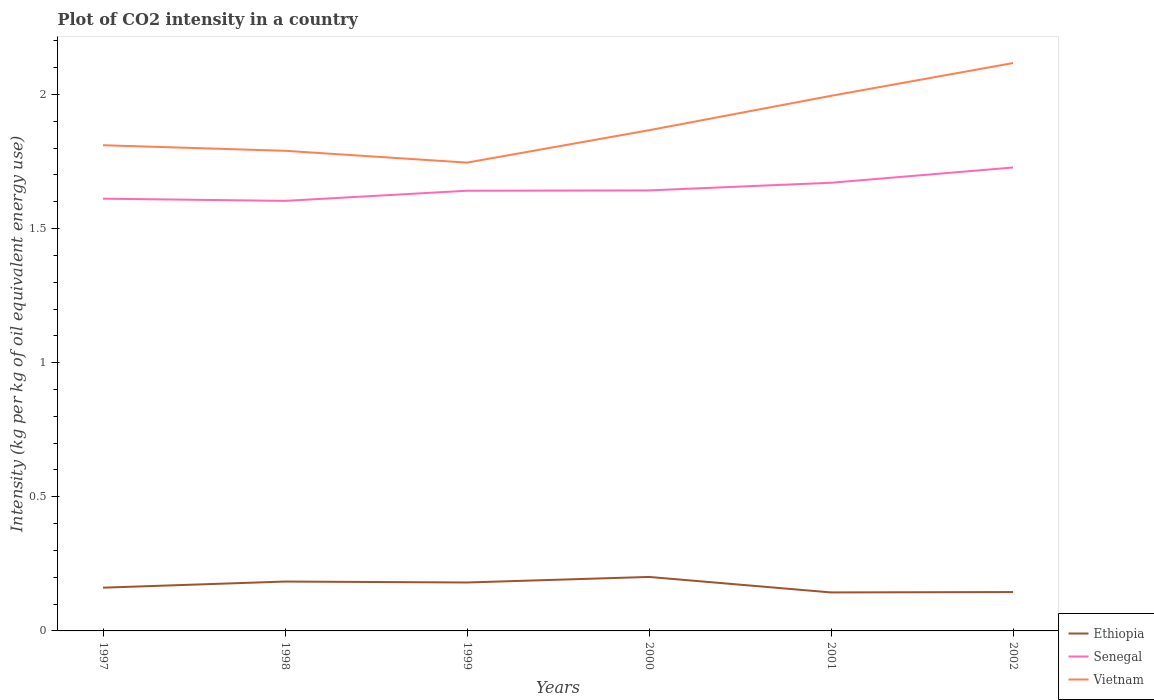How many different coloured lines are there?
Provide a short and direct response. 3. Across all years, what is the maximum CO2 intensity in in Vietnam?
Provide a short and direct response. 1.75. In which year was the CO2 intensity in in Vietnam maximum?
Your answer should be very brief. 1999. What is the total CO2 intensity in in Senegal in the graph?
Offer a terse response. -0.04. What is the difference between the highest and the second highest CO2 intensity in in Senegal?
Your response must be concise. 0.12. Is the CO2 intensity in in Vietnam strictly greater than the CO2 intensity in in Ethiopia over the years?
Give a very brief answer. No. How many years are there in the graph?
Keep it short and to the point. 6. What is the difference between two consecutive major ticks on the Y-axis?
Give a very brief answer. 0.5. Are the values on the major ticks of Y-axis written in scientific E-notation?
Provide a succinct answer. No. Where does the legend appear in the graph?
Ensure brevity in your answer.  Bottom right. How are the legend labels stacked?
Your response must be concise. Vertical. What is the title of the graph?
Provide a short and direct response. Plot of CO2 intensity in a country. What is the label or title of the X-axis?
Give a very brief answer. Years. What is the label or title of the Y-axis?
Your answer should be compact. Intensity (kg per kg of oil equivalent energy use). What is the Intensity (kg per kg of oil equivalent energy use) of Ethiopia in 1997?
Make the answer very short. 0.16. What is the Intensity (kg per kg of oil equivalent energy use) in Senegal in 1997?
Provide a short and direct response. 1.61. What is the Intensity (kg per kg of oil equivalent energy use) of Vietnam in 1997?
Provide a short and direct response. 1.81. What is the Intensity (kg per kg of oil equivalent energy use) of Ethiopia in 1998?
Your response must be concise. 0.18. What is the Intensity (kg per kg of oil equivalent energy use) in Senegal in 1998?
Your response must be concise. 1.6. What is the Intensity (kg per kg of oil equivalent energy use) of Vietnam in 1998?
Provide a succinct answer. 1.79. What is the Intensity (kg per kg of oil equivalent energy use) in Ethiopia in 1999?
Ensure brevity in your answer.  0.18. What is the Intensity (kg per kg of oil equivalent energy use) in Senegal in 1999?
Give a very brief answer. 1.64. What is the Intensity (kg per kg of oil equivalent energy use) of Vietnam in 1999?
Your response must be concise. 1.75. What is the Intensity (kg per kg of oil equivalent energy use) of Ethiopia in 2000?
Offer a terse response. 0.2. What is the Intensity (kg per kg of oil equivalent energy use) in Senegal in 2000?
Offer a terse response. 1.64. What is the Intensity (kg per kg of oil equivalent energy use) of Vietnam in 2000?
Provide a short and direct response. 1.87. What is the Intensity (kg per kg of oil equivalent energy use) in Ethiopia in 2001?
Provide a succinct answer. 0.14. What is the Intensity (kg per kg of oil equivalent energy use) in Senegal in 2001?
Provide a succinct answer. 1.67. What is the Intensity (kg per kg of oil equivalent energy use) in Vietnam in 2001?
Keep it short and to the point. 2. What is the Intensity (kg per kg of oil equivalent energy use) of Ethiopia in 2002?
Make the answer very short. 0.14. What is the Intensity (kg per kg of oil equivalent energy use) in Senegal in 2002?
Provide a succinct answer. 1.73. What is the Intensity (kg per kg of oil equivalent energy use) of Vietnam in 2002?
Your answer should be very brief. 2.12. Across all years, what is the maximum Intensity (kg per kg of oil equivalent energy use) in Ethiopia?
Give a very brief answer. 0.2. Across all years, what is the maximum Intensity (kg per kg of oil equivalent energy use) in Senegal?
Offer a terse response. 1.73. Across all years, what is the maximum Intensity (kg per kg of oil equivalent energy use) of Vietnam?
Make the answer very short. 2.12. Across all years, what is the minimum Intensity (kg per kg of oil equivalent energy use) of Ethiopia?
Provide a short and direct response. 0.14. Across all years, what is the minimum Intensity (kg per kg of oil equivalent energy use) in Senegal?
Make the answer very short. 1.6. Across all years, what is the minimum Intensity (kg per kg of oil equivalent energy use) in Vietnam?
Give a very brief answer. 1.75. What is the total Intensity (kg per kg of oil equivalent energy use) of Ethiopia in the graph?
Offer a very short reply. 1.02. What is the total Intensity (kg per kg of oil equivalent energy use) in Senegal in the graph?
Your answer should be compact. 9.9. What is the total Intensity (kg per kg of oil equivalent energy use) in Vietnam in the graph?
Provide a succinct answer. 11.33. What is the difference between the Intensity (kg per kg of oil equivalent energy use) of Ethiopia in 1997 and that in 1998?
Your answer should be compact. -0.02. What is the difference between the Intensity (kg per kg of oil equivalent energy use) of Senegal in 1997 and that in 1998?
Keep it short and to the point. 0.01. What is the difference between the Intensity (kg per kg of oil equivalent energy use) of Vietnam in 1997 and that in 1998?
Your response must be concise. 0.02. What is the difference between the Intensity (kg per kg of oil equivalent energy use) in Ethiopia in 1997 and that in 1999?
Provide a succinct answer. -0.02. What is the difference between the Intensity (kg per kg of oil equivalent energy use) of Senegal in 1997 and that in 1999?
Give a very brief answer. -0.03. What is the difference between the Intensity (kg per kg of oil equivalent energy use) of Vietnam in 1997 and that in 1999?
Your answer should be very brief. 0.06. What is the difference between the Intensity (kg per kg of oil equivalent energy use) of Ethiopia in 1997 and that in 2000?
Keep it short and to the point. -0.04. What is the difference between the Intensity (kg per kg of oil equivalent energy use) in Senegal in 1997 and that in 2000?
Keep it short and to the point. -0.03. What is the difference between the Intensity (kg per kg of oil equivalent energy use) of Vietnam in 1997 and that in 2000?
Give a very brief answer. -0.06. What is the difference between the Intensity (kg per kg of oil equivalent energy use) of Ethiopia in 1997 and that in 2001?
Your answer should be compact. 0.02. What is the difference between the Intensity (kg per kg of oil equivalent energy use) of Senegal in 1997 and that in 2001?
Provide a succinct answer. -0.06. What is the difference between the Intensity (kg per kg of oil equivalent energy use) of Vietnam in 1997 and that in 2001?
Provide a short and direct response. -0.18. What is the difference between the Intensity (kg per kg of oil equivalent energy use) in Ethiopia in 1997 and that in 2002?
Keep it short and to the point. 0.02. What is the difference between the Intensity (kg per kg of oil equivalent energy use) of Senegal in 1997 and that in 2002?
Your answer should be very brief. -0.12. What is the difference between the Intensity (kg per kg of oil equivalent energy use) in Vietnam in 1997 and that in 2002?
Provide a succinct answer. -0.31. What is the difference between the Intensity (kg per kg of oil equivalent energy use) of Ethiopia in 1998 and that in 1999?
Provide a short and direct response. 0. What is the difference between the Intensity (kg per kg of oil equivalent energy use) of Senegal in 1998 and that in 1999?
Your answer should be very brief. -0.04. What is the difference between the Intensity (kg per kg of oil equivalent energy use) of Vietnam in 1998 and that in 1999?
Your response must be concise. 0.04. What is the difference between the Intensity (kg per kg of oil equivalent energy use) in Ethiopia in 1998 and that in 2000?
Ensure brevity in your answer.  -0.02. What is the difference between the Intensity (kg per kg of oil equivalent energy use) in Senegal in 1998 and that in 2000?
Give a very brief answer. -0.04. What is the difference between the Intensity (kg per kg of oil equivalent energy use) in Vietnam in 1998 and that in 2000?
Provide a succinct answer. -0.08. What is the difference between the Intensity (kg per kg of oil equivalent energy use) of Ethiopia in 1998 and that in 2001?
Your response must be concise. 0.04. What is the difference between the Intensity (kg per kg of oil equivalent energy use) of Senegal in 1998 and that in 2001?
Your response must be concise. -0.07. What is the difference between the Intensity (kg per kg of oil equivalent energy use) of Vietnam in 1998 and that in 2001?
Provide a short and direct response. -0.2. What is the difference between the Intensity (kg per kg of oil equivalent energy use) of Ethiopia in 1998 and that in 2002?
Your response must be concise. 0.04. What is the difference between the Intensity (kg per kg of oil equivalent energy use) of Senegal in 1998 and that in 2002?
Make the answer very short. -0.12. What is the difference between the Intensity (kg per kg of oil equivalent energy use) of Vietnam in 1998 and that in 2002?
Offer a very short reply. -0.33. What is the difference between the Intensity (kg per kg of oil equivalent energy use) in Ethiopia in 1999 and that in 2000?
Give a very brief answer. -0.02. What is the difference between the Intensity (kg per kg of oil equivalent energy use) of Senegal in 1999 and that in 2000?
Your response must be concise. -0. What is the difference between the Intensity (kg per kg of oil equivalent energy use) in Vietnam in 1999 and that in 2000?
Keep it short and to the point. -0.12. What is the difference between the Intensity (kg per kg of oil equivalent energy use) of Ethiopia in 1999 and that in 2001?
Ensure brevity in your answer.  0.04. What is the difference between the Intensity (kg per kg of oil equivalent energy use) in Senegal in 1999 and that in 2001?
Your answer should be very brief. -0.03. What is the difference between the Intensity (kg per kg of oil equivalent energy use) of Vietnam in 1999 and that in 2001?
Make the answer very short. -0.25. What is the difference between the Intensity (kg per kg of oil equivalent energy use) in Ethiopia in 1999 and that in 2002?
Your response must be concise. 0.04. What is the difference between the Intensity (kg per kg of oil equivalent energy use) of Senegal in 1999 and that in 2002?
Provide a short and direct response. -0.09. What is the difference between the Intensity (kg per kg of oil equivalent energy use) in Vietnam in 1999 and that in 2002?
Give a very brief answer. -0.37. What is the difference between the Intensity (kg per kg of oil equivalent energy use) of Ethiopia in 2000 and that in 2001?
Your answer should be very brief. 0.06. What is the difference between the Intensity (kg per kg of oil equivalent energy use) of Senegal in 2000 and that in 2001?
Give a very brief answer. -0.03. What is the difference between the Intensity (kg per kg of oil equivalent energy use) in Vietnam in 2000 and that in 2001?
Provide a short and direct response. -0.13. What is the difference between the Intensity (kg per kg of oil equivalent energy use) in Ethiopia in 2000 and that in 2002?
Your answer should be very brief. 0.06. What is the difference between the Intensity (kg per kg of oil equivalent energy use) in Senegal in 2000 and that in 2002?
Make the answer very short. -0.09. What is the difference between the Intensity (kg per kg of oil equivalent energy use) in Vietnam in 2000 and that in 2002?
Your answer should be very brief. -0.25. What is the difference between the Intensity (kg per kg of oil equivalent energy use) in Ethiopia in 2001 and that in 2002?
Keep it short and to the point. -0. What is the difference between the Intensity (kg per kg of oil equivalent energy use) in Senegal in 2001 and that in 2002?
Keep it short and to the point. -0.06. What is the difference between the Intensity (kg per kg of oil equivalent energy use) of Vietnam in 2001 and that in 2002?
Provide a short and direct response. -0.12. What is the difference between the Intensity (kg per kg of oil equivalent energy use) in Ethiopia in 1997 and the Intensity (kg per kg of oil equivalent energy use) in Senegal in 1998?
Offer a terse response. -1.44. What is the difference between the Intensity (kg per kg of oil equivalent energy use) in Ethiopia in 1997 and the Intensity (kg per kg of oil equivalent energy use) in Vietnam in 1998?
Ensure brevity in your answer.  -1.63. What is the difference between the Intensity (kg per kg of oil equivalent energy use) of Senegal in 1997 and the Intensity (kg per kg of oil equivalent energy use) of Vietnam in 1998?
Give a very brief answer. -0.18. What is the difference between the Intensity (kg per kg of oil equivalent energy use) in Ethiopia in 1997 and the Intensity (kg per kg of oil equivalent energy use) in Senegal in 1999?
Offer a very short reply. -1.48. What is the difference between the Intensity (kg per kg of oil equivalent energy use) in Ethiopia in 1997 and the Intensity (kg per kg of oil equivalent energy use) in Vietnam in 1999?
Give a very brief answer. -1.58. What is the difference between the Intensity (kg per kg of oil equivalent energy use) of Senegal in 1997 and the Intensity (kg per kg of oil equivalent energy use) of Vietnam in 1999?
Your answer should be very brief. -0.13. What is the difference between the Intensity (kg per kg of oil equivalent energy use) in Ethiopia in 1997 and the Intensity (kg per kg of oil equivalent energy use) in Senegal in 2000?
Your answer should be very brief. -1.48. What is the difference between the Intensity (kg per kg of oil equivalent energy use) in Ethiopia in 1997 and the Intensity (kg per kg of oil equivalent energy use) in Vietnam in 2000?
Your answer should be very brief. -1.71. What is the difference between the Intensity (kg per kg of oil equivalent energy use) in Senegal in 1997 and the Intensity (kg per kg of oil equivalent energy use) in Vietnam in 2000?
Provide a succinct answer. -0.26. What is the difference between the Intensity (kg per kg of oil equivalent energy use) of Ethiopia in 1997 and the Intensity (kg per kg of oil equivalent energy use) of Senegal in 2001?
Your answer should be compact. -1.51. What is the difference between the Intensity (kg per kg of oil equivalent energy use) in Ethiopia in 1997 and the Intensity (kg per kg of oil equivalent energy use) in Vietnam in 2001?
Your answer should be compact. -1.83. What is the difference between the Intensity (kg per kg of oil equivalent energy use) of Senegal in 1997 and the Intensity (kg per kg of oil equivalent energy use) of Vietnam in 2001?
Ensure brevity in your answer.  -0.38. What is the difference between the Intensity (kg per kg of oil equivalent energy use) in Ethiopia in 1997 and the Intensity (kg per kg of oil equivalent energy use) in Senegal in 2002?
Your response must be concise. -1.57. What is the difference between the Intensity (kg per kg of oil equivalent energy use) in Ethiopia in 1997 and the Intensity (kg per kg of oil equivalent energy use) in Vietnam in 2002?
Ensure brevity in your answer.  -1.96. What is the difference between the Intensity (kg per kg of oil equivalent energy use) of Senegal in 1997 and the Intensity (kg per kg of oil equivalent energy use) of Vietnam in 2002?
Provide a short and direct response. -0.51. What is the difference between the Intensity (kg per kg of oil equivalent energy use) of Ethiopia in 1998 and the Intensity (kg per kg of oil equivalent energy use) of Senegal in 1999?
Your answer should be compact. -1.46. What is the difference between the Intensity (kg per kg of oil equivalent energy use) in Ethiopia in 1998 and the Intensity (kg per kg of oil equivalent energy use) in Vietnam in 1999?
Make the answer very short. -1.56. What is the difference between the Intensity (kg per kg of oil equivalent energy use) of Senegal in 1998 and the Intensity (kg per kg of oil equivalent energy use) of Vietnam in 1999?
Make the answer very short. -0.14. What is the difference between the Intensity (kg per kg of oil equivalent energy use) in Ethiopia in 1998 and the Intensity (kg per kg of oil equivalent energy use) in Senegal in 2000?
Your response must be concise. -1.46. What is the difference between the Intensity (kg per kg of oil equivalent energy use) in Ethiopia in 1998 and the Intensity (kg per kg of oil equivalent energy use) in Vietnam in 2000?
Your response must be concise. -1.68. What is the difference between the Intensity (kg per kg of oil equivalent energy use) in Senegal in 1998 and the Intensity (kg per kg of oil equivalent energy use) in Vietnam in 2000?
Provide a succinct answer. -0.26. What is the difference between the Intensity (kg per kg of oil equivalent energy use) of Ethiopia in 1998 and the Intensity (kg per kg of oil equivalent energy use) of Senegal in 2001?
Your answer should be compact. -1.49. What is the difference between the Intensity (kg per kg of oil equivalent energy use) in Ethiopia in 1998 and the Intensity (kg per kg of oil equivalent energy use) in Vietnam in 2001?
Offer a very short reply. -1.81. What is the difference between the Intensity (kg per kg of oil equivalent energy use) of Senegal in 1998 and the Intensity (kg per kg of oil equivalent energy use) of Vietnam in 2001?
Your answer should be very brief. -0.39. What is the difference between the Intensity (kg per kg of oil equivalent energy use) of Ethiopia in 1998 and the Intensity (kg per kg of oil equivalent energy use) of Senegal in 2002?
Give a very brief answer. -1.54. What is the difference between the Intensity (kg per kg of oil equivalent energy use) of Ethiopia in 1998 and the Intensity (kg per kg of oil equivalent energy use) of Vietnam in 2002?
Offer a very short reply. -1.93. What is the difference between the Intensity (kg per kg of oil equivalent energy use) in Senegal in 1998 and the Intensity (kg per kg of oil equivalent energy use) in Vietnam in 2002?
Your answer should be compact. -0.51. What is the difference between the Intensity (kg per kg of oil equivalent energy use) of Ethiopia in 1999 and the Intensity (kg per kg of oil equivalent energy use) of Senegal in 2000?
Ensure brevity in your answer.  -1.46. What is the difference between the Intensity (kg per kg of oil equivalent energy use) of Ethiopia in 1999 and the Intensity (kg per kg of oil equivalent energy use) of Vietnam in 2000?
Offer a terse response. -1.69. What is the difference between the Intensity (kg per kg of oil equivalent energy use) of Senegal in 1999 and the Intensity (kg per kg of oil equivalent energy use) of Vietnam in 2000?
Ensure brevity in your answer.  -0.23. What is the difference between the Intensity (kg per kg of oil equivalent energy use) of Ethiopia in 1999 and the Intensity (kg per kg of oil equivalent energy use) of Senegal in 2001?
Ensure brevity in your answer.  -1.49. What is the difference between the Intensity (kg per kg of oil equivalent energy use) in Ethiopia in 1999 and the Intensity (kg per kg of oil equivalent energy use) in Vietnam in 2001?
Your response must be concise. -1.81. What is the difference between the Intensity (kg per kg of oil equivalent energy use) of Senegal in 1999 and the Intensity (kg per kg of oil equivalent energy use) of Vietnam in 2001?
Provide a short and direct response. -0.35. What is the difference between the Intensity (kg per kg of oil equivalent energy use) in Ethiopia in 1999 and the Intensity (kg per kg of oil equivalent energy use) in Senegal in 2002?
Ensure brevity in your answer.  -1.55. What is the difference between the Intensity (kg per kg of oil equivalent energy use) in Ethiopia in 1999 and the Intensity (kg per kg of oil equivalent energy use) in Vietnam in 2002?
Ensure brevity in your answer.  -1.94. What is the difference between the Intensity (kg per kg of oil equivalent energy use) of Senegal in 1999 and the Intensity (kg per kg of oil equivalent energy use) of Vietnam in 2002?
Provide a succinct answer. -0.48. What is the difference between the Intensity (kg per kg of oil equivalent energy use) of Ethiopia in 2000 and the Intensity (kg per kg of oil equivalent energy use) of Senegal in 2001?
Ensure brevity in your answer.  -1.47. What is the difference between the Intensity (kg per kg of oil equivalent energy use) of Ethiopia in 2000 and the Intensity (kg per kg of oil equivalent energy use) of Vietnam in 2001?
Give a very brief answer. -1.79. What is the difference between the Intensity (kg per kg of oil equivalent energy use) in Senegal in 2000 and the Intensity (kg per kg of oil equivalent energy use) in Vietnam in 2001?
Give a very brief answer. -0.35. What is the difference between the Intensity (kg per kg of oil equivalent energy use) of Ethiopia in 2000 and the Intensity (kg per kg of oil equivalent energy use) of Senegal in 2002?
Your response must be concise. -1.53. What is the difference between the Intensity (kg per kg of oil equivalent energy use) in Ethiopia in 2000 and the Intensity (kg per kg of oil equivalent energy use) in Vietnam in 2002?
Your response must be concise. -1.92. What is the difference between the Intensity (kg per kg of oil equivalent energy use) in Senegal in 2000 and the Intensity (kg per kg of oil equivalent energy use) in Vietnam in 2002?
Offer a terse response. -0.47. What is the difference between the Intensity (kg per kg of oil equivalent energy use) in Ethiopia in 2001 and the Intensity (kg per kg of oil equivalent energy use) in Senegal in 2002?
Offer a terse response. -1.58. What is the difference between the Intensity (kg per kg of oil equivalent energy use) in Ethiopia in 2001 and the Intensity (kg per kg of oil equivalent energy use) in Vietnam in 2002?
Make the answer very short. -1.97. What is the difference between the Intensity (kg per kg of oil equivalent energy use) of Senegal in 2001 and the Intensity (kg per kg of oil equivalent energy use) of Vietnam in 2002?
Provide a short and direct response. -0.45. What is the average Intensity (kg per kg of oil equivalent energy use) in Ethiopia per year?
Give a very brief answer. 0.17. What is the average Intensity (kg per kg of oil equivalent energy use) in Senegal per year?
Keep it short and to the point. 1.65. What is the average Intensity (kg per kg of oil equivalent energy use) in Vietnam per year?
Your response must be concise. 1.89. In the year 1997, what is the difference between the Intensity (kg per kg of oil equivalent energy use) in Ethiopia and Intensity (kg per kg of oil equivalent energy use) in Senegal?
Offer a very short reply. -1.45. In the year 1997, what is the difference between the Intensity (kg per kg of oil equivalent energy use) in Ethiopia and Intensity (kg per kg of oil equivalent energy use) in Vietnam?
Ensure brevity in your answer.  -1.65. In the year 1997, what is the difference between the Intensity (kg per kg of oil equivalent energy use) in Senegal and Intensity (kg per kg of oil equivalent energy use) in Vietnam?
Your answer should be compact. -0.2. In the year 1998, what is the difference between the Intensity (kg per kg of oil equivalent energy use) in Ethiopia and Intensity (kg per kg of oil equivalent energy use) in Senegal?
Offer a terse response. -1.42. In the year 1998, what is the difference between the Intensity (kg per kg of oil equivalent energy use) in Ethiopia and Intensity (kg per kg of oil equivalent energy use) in Vietnam?
Keep it short and to the point. -1.61. In the year 1998, what is the difference between the Intensity (kg per kg of oil equivalent energy use) of Senegal and Intensity (kg per kg of oil equivalent energy use) of Vietnam?
Your answer should be very brief. -0.19. In the year 1999, what is the difference between the Intensity (kg per kg of oil equivalent energy use) of Ethiopia and Intensity (kg per kg of oil equivalent energy use) of Senegal?
Give a very brief answer. -1.46. In the year 1999, what is the difference between the Intensity (kg per kg of oil equivalent energy use) in Ethiopia and Intensity (kg per kg of oil equivalent energy use) in Vietnam?
Your response must be concise. -1.57. In the year 1999, what is the difference between the Intensity (kg per kg of oil equivalent energy use) in Senegal and Intensity (kg per kg of oil equivalent energy use) in Vietnam?
Your response must be concise. -0.1. In the year 2000, what is the difference between the Intensity (kg per kg of oil equivalent energy use) of Ethiopia and Intensity (kg per kg of oil equivalent energy use) of Senegal?
Your answer should be very brief. -1.44. In the year 2000, what is the difference between the Intensity (kg per kg of oil equivalent energy use) in Ethiopia and Intensity (kg per kg of oil equivalent energy use) in Vietnam?
Provide a succinct answer. -1.67. In the year 2000, what is the difference between the Intensity (kg per kg of oil equivalent energy use) in Senegal and Intensity (kg per kg of oil equivalent energy use) in Vietnam?
Your answer should be compact. -0.22. In the year 2001, what is the difference between the Intensity (kg per kg of oil equivalent energy use) of Ethiopia and Intensity (kg per kg of oil equivalent energy use) of Senegal?
Give a very brief answer. -1.53. In the year 2001, what is the difference between the Intensity (kg per kg of oil equivalent energy use) of Ethiopia and Intensity (kg per kg of oil equivalent energy use) of Vietnam?
Offer a terse response. -1.85. In the year 2001, what is the difference between the Intensity (kg per kg of oil equivalent energy use) of Senegal and Intensity (kg per kg of oil equivalent energy use) of Vietnam?
Your response must be concise. -0.32. In the year 2002, what is the difference between the Intensity (kg per kg of oil equivalent energy use) of Ethiopia and Intensity (kg per kg of oil equivalent energy use) of Senegal?
Provide a short and direct response. -1.58. In the year 2002, what is the difference between the Intensity (kg per kg of oil equivalent energy use) of Ethiopia and Intensity (kg per kg of oil equivalent energy use) of Vietnam?
Ensure brevity in your answer.  -1.97. In the year 2002, what is the difference between the Intensity (kg per kg of oil equivalent energy use) in Senegal and Intensity (kg per kg of oil equivalent energy use) in Vietnam?
Ensure brevity in your answer.  -0.39. What is the ratio of the Intensity (kg per kg of oil equivalent energy use) of Ethiopia in 1997 to that in 1998?
Keep it short and to the point. 0.88. What is the ratio of the Intensity (kg per kg of oil equivalent energy use) in Senegal in 1997 to that in 1998?
Provide a succinct answer. 1.01. What is the ratio of the Intensity (kg per kg of oil equivalent energy use) of Vietnam in 1997 to that in 1998?
Keep it short and to the point. 1.01. What is the ratio of the Intensity (kg per kg of oil equivalent energy use) in Ethiopia in 1997 to that in 1999?
Offer a very short reply. 0.89. What is the ratio of the Intensity (kg per kg of oil equivalent energy use) in Senegal in 1997 to that in 1999?
Your answer should be very brief. 0.98. What is the ratio of the Intensity (kg per kg of oil equivalent energy use) in Vietnam in 1997 to that in 1999?
Provide a short and direct response. 1.04. What is the ratio of the Intensity (kg per kg of oil equivalent energy use) in Ethiopia in 1997 to that in 2000?
Provide a succinct answer. 0.8. What is the ratio of the Intensity (kg per kg of oil equivalent energy use) in Senegal in 1997 to that in 2000?
Give a very brief answer. 0.98. What is the ratio of the Intensity (kg per kg of oil equivalent energy use) in Vietnam in 1997 to that in 2000?
Offer a terse response. 0.97. What is the ratio of the Intensity (kg per kg of oil equivalent energy use) of Ethiopia in 1997 to that in 2001?
Give a very brief answer. 1.12. What is the ratio of the Intensity (kg per kg of oil equivalent energy use) of Senegal in 1997 to that in 2001?
Provide a succinct answer. 0.96. What is the ratio of the Intensity (kg per kg of oil equivalent energy use) of Vietnam in 1997 to that in 2001?
Make the answer very short. 0.91. What is the ratio of the Intensity (kg per kg of oil equivalent energy use) of Ethiopia in 1997 to that in 2002?
Offer a terse response. 1.11. What is the ratio of the Intensity (kg per kg of oil equivalent energy use) of Senegal in 1997 to that in 2002?
Your answer should be compact. 0.93. What is the ratio of the Intensity (kg per kg of oil equivalent energy use) of Vietnam in 1997 to that in 2002?
Offer a terse response. 0.86. What is the ratio of the Intensity (kg per kg of oil equivalent energy use) of Ethiopia in 1998 to that in 1999?
Your answer should be compact. 1.02. What is the ratio of the Intensity (kg per kg of oil equivalent energy use) in Senegal in 1998 to that in 1999?
Your answer should be compact. 0.98. What is the ratio of the Intensity (kg per kg of oil equivalent energy use) in Vietnam in 1998 to that in 1999?
Your answer should be compact. 1.03. What is the ratio of the Intensity (kg per kg of oil equivalent energy use) in Ethiopia in 1998 to that in 2000?
Make the answer very short. 0.91. What is the ratio of the Intensity (kg per kg of oil equivalent energy use) of Senegal in 1998 to that in 2000?
Ensure brevity in your answer.  0.98. What is the ratio of the Intensity (kg per kg of oil equivalent energy use) in Vietnam in 1998 to that in 2000?
Ensure brevity in your answer.  0.96. What is the ratio of the Intensity (kg per kg of oil equivalent energy use) of Ethiopia in 1998 to that in 2001?
Offer a very short reply. 1.28. What is the ratio of the Intensity (kg per kg of oil equivalent energy use) in Senegal in 1998 to that in 2001?
Provide a succinct answer. 0.96. What is the ratio of the Intensity (kg per kg of oil equivalent energy use) of Vietnam in 1998 to that in 2001?
Provide a succinct answer. 0.9. What is the ratio of the Intensity (kg per kg of oil equivalent energy use) in Ethiopia in 1998 to that in 2002?
Provide a short and direct response. 1.27. What is the ratio of the Intensity (kg per kg of oil equivalent energy use) of Senegal in 1998 to that in 2002?
Offer a terse response. 0.93. What is the ratio of the Intensity (kg per kg of oil equivalent energy use) in Vietnam in 1998 to that in 2002?
Your answer should be compact. 0.85. What is the ratio of the Intensity (kg per kg of oil equivalent energy use) of Ethiopia in 1999 to that in 2000?
Offer a very short reply. 0.9. What is the ratio of the Intensity (kg per kg of oil equivalent energy use) in Vietnam in 1999 to that in 2000?
Keep it short and to the point. 0.94. What is the ratio of the Intensity (kg per kg of oil equivalent energy use) of Ethiopia in 1999 to that in 2001?
Provide a succinct answer. 1.26. What is the ratio of the Intensity (kg per kg of oil equivalent energy use) in Senegal in 1999 to that in 2001?
Offer a terse response. 0.98. What is the ratio of the Intensity (kg per kg of oil equivalent energy use) in Vietnam in 1999 to that in 2001?
Ensure brevity in your answer.  0.88. What is the ratio of the Intensity (kg per kg of oil equivalent energy use) of Ethiopia in 1999 to that in 2002?
Provide a short and direct response. 1.25. What is the ratio of the Intensity (kg per kg of oil equivalent energy use) of Senegal in 1999 to that in 2002?
Provide a succinct answer. 0.95. What is the ratio of the Intensity (kg per kg of oil equivalent energy use) of Vietnam in 1999 to that in 2002?
Make the answer very short. 0.82. What is the ratio of the Intensity (kg per kg of oil equivalent energy use) in Ethiopia in 2000 to that in 2001?
Your response must be concise. 1.4. What is the ratio of the Intensity (kg per kg of oil equivalent energy use) of Senegal in 2000 to that in 2001?
Keep it short and to the point. 0.98. What is the ratio of the Intensity (kg per kg of oil equivalent energy use) of Vietnam in 2000 to that in 2001?
Provide a succinct answer. 0.94. What is the ratio of the Intensity (kg per kg of oil equivalent energy use) of Ethiopia in 2000 to that in 2002?
Offer a terse response. 1.39. What is the ratio of the Intensity (kg per kg of oil equivalent energy use) of Senegal in 2000 to that in 2002?
Your response must be concise. 0.95. What is the ratio of the Intensity (kg per kg of oil equivalent energy use) of Vietnam in 2000 to that in 2002?
Offer a terse response. 0.88. What is the ratio of the Intensity (kg per kg of oil equivalent energy use) in Senegal in 2001 to that in 2002?
Offer a very short reply. 0.97. What is the ratio of the Intensity (kg per kg of oil equivalent energy use) of Vietnam in 2001 to that in 2002?
Provide a short and direct response. 0.94. What is the difference between the highest and the second highest Intensity (kg per kg of oil equivalent energy use) of Ethiopia?
Your answer should be very brief. 0.02. What is the difference between the highest and the second highest Intensity (kg per kg of oil equivalent energy use) of Senegal?
Your response must be concise. 0.06. What is the difference between the highest and the second highest Intensity (kg per kg of oil equivalent energy use) in Vietnam?
Provide a succinct answer. 0.12. What is the difference between the highest and the lowest Intensity (kg per kg of oil equivalent energy use) of Ethiopia?
Your answer should be compact. 0.06. What is the difference between the highest and the lowest Intensity (kg per kg of oil equivalent energy use) of Senegal?
Offer a terse response. 0.12. What is the difference between the highest and the lowest Intensity (kg per kg of oil equivalent energy use) of Vietnam?
Ensure brevity in your answer.  0.37. 